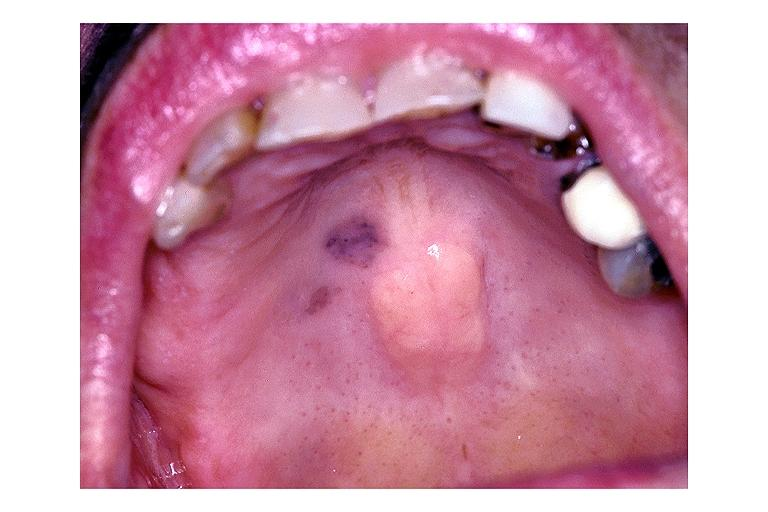what is present?
Answer the question using a single word or phrase. Oral 